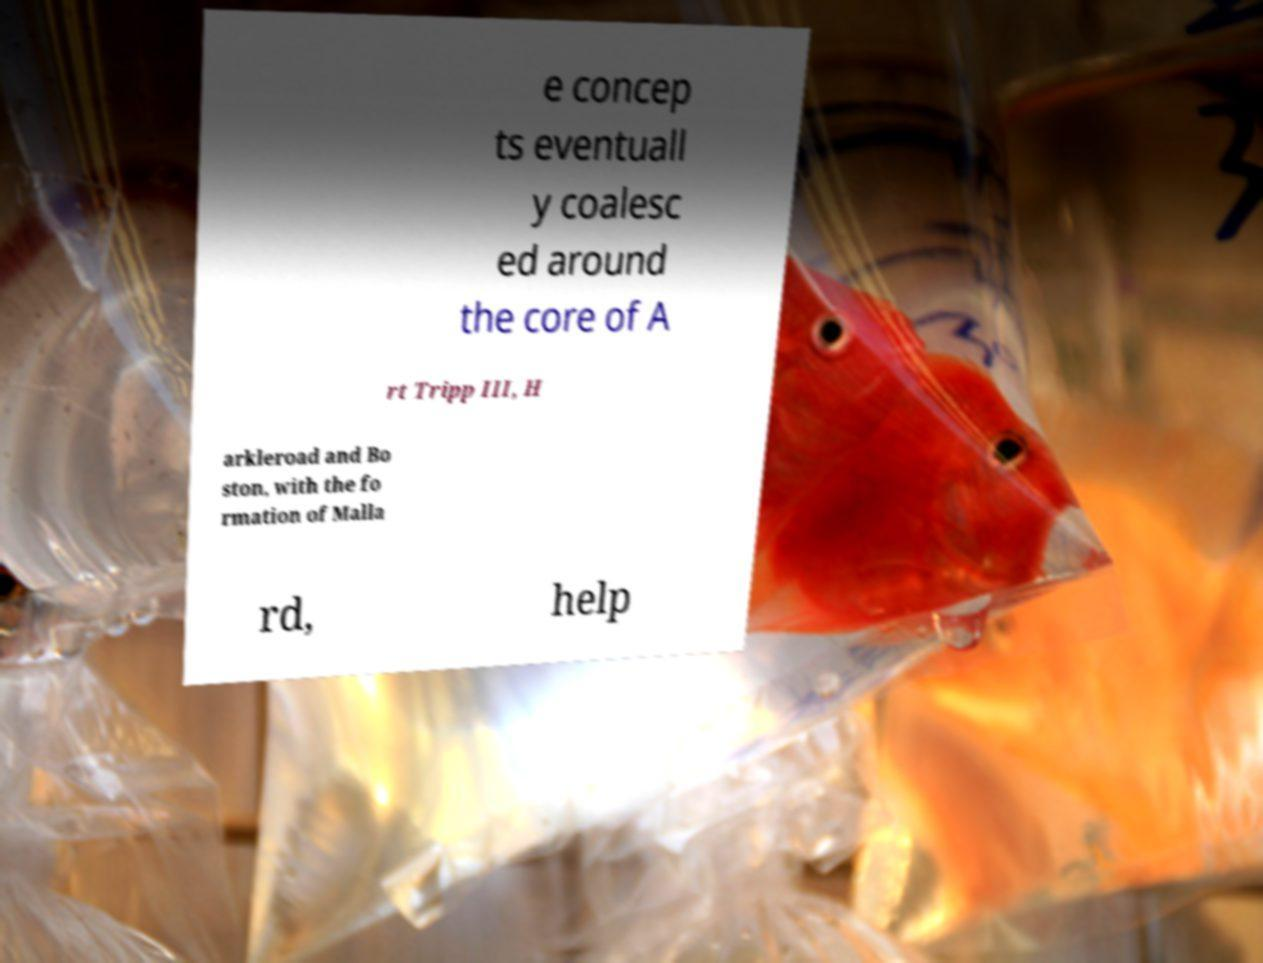Can you read and provide the text displayed in the image?This photo seems to have some interesting text. Can you extract and type it out for me? e concep ts eventuall y coalesc ed around the core of A rt Tripp III, H arkleroad and Bo ston, with the fo rmation of Malla rd, help 